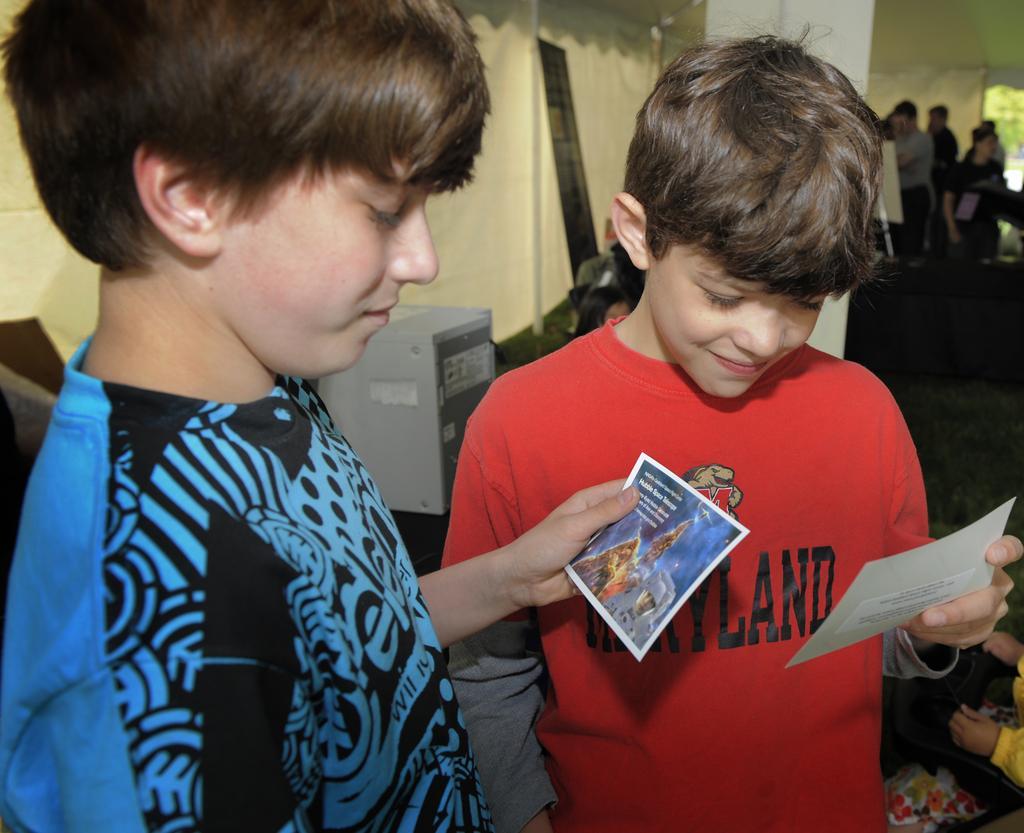Can you describe this image briefly? There are two kids standing and holding a sheet of paper in their hand which has some thing written on it and there are few other people in the right corner. 